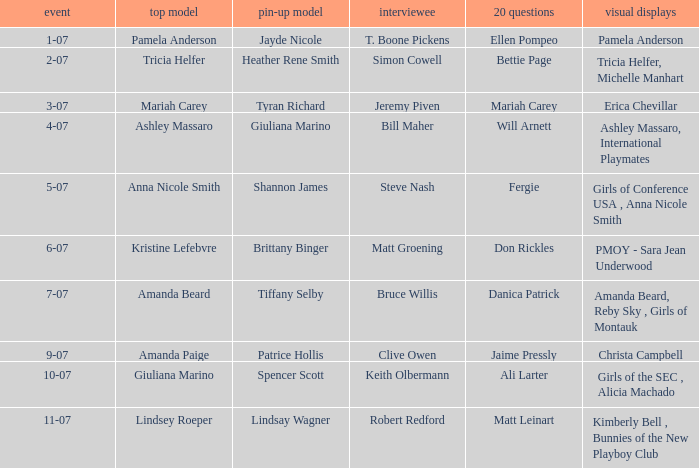Who answered the 20 questions on 10-07? Ali Larter. 